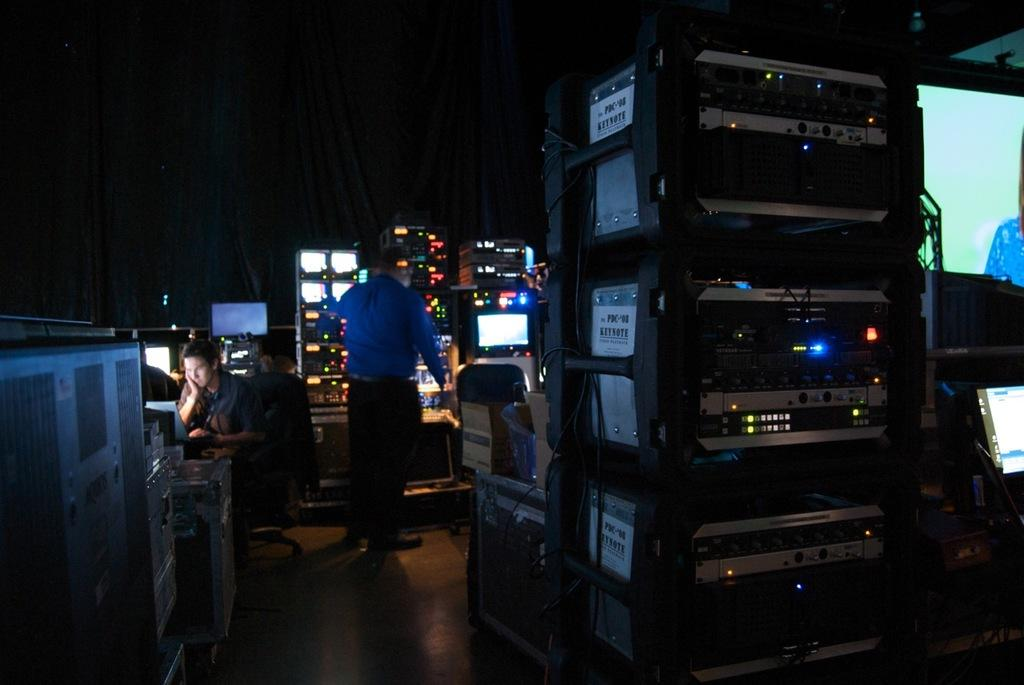What type of objects can be seen in the image? There are electronic devices in the image. How many people are in the room? There are two people in the room. What are the positions of the people in the room? One person is sitting, and one person is standing. Where is the screen located in the image? The screen is on the right side of the image. What type of boundary can be seen in the image? There is no boundary present in the image. Is there a scarecrow visible in the image? No, there is no scarecrow present in the image. 